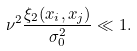<formula> <loc_0><loc_0><loc_500><loc_500>\nu ^ { 2 } \frac { \xi _ { 2 } ( x _ { i } , x _ { j } ) } { \sigma _ { 0 } ^ { 2 } } \ll 1 .</formula> 